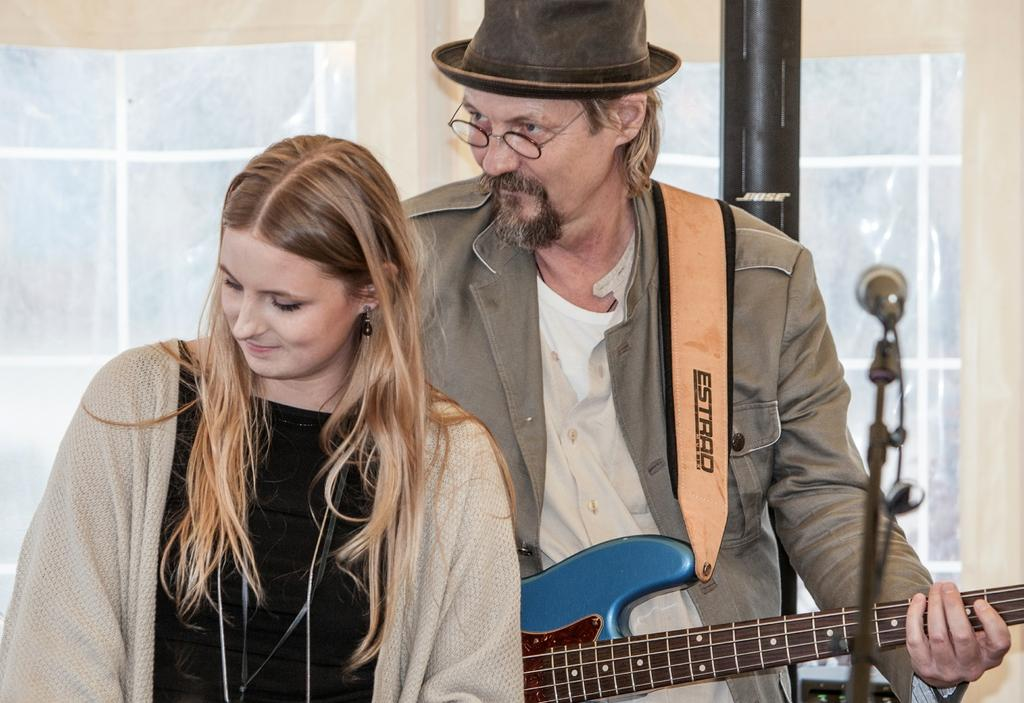How many people are in the image? There are two people in the image, a woman and a man. What is the man holding in the image? The man is holding a guitar. What accessories is the man wearing in the image? The man is wearing a cap and specs. What object is present in front of them in the image? There is a microphone in front of them. What color is the silver line of hope in the image? There is no silver line of hope present in the image. 